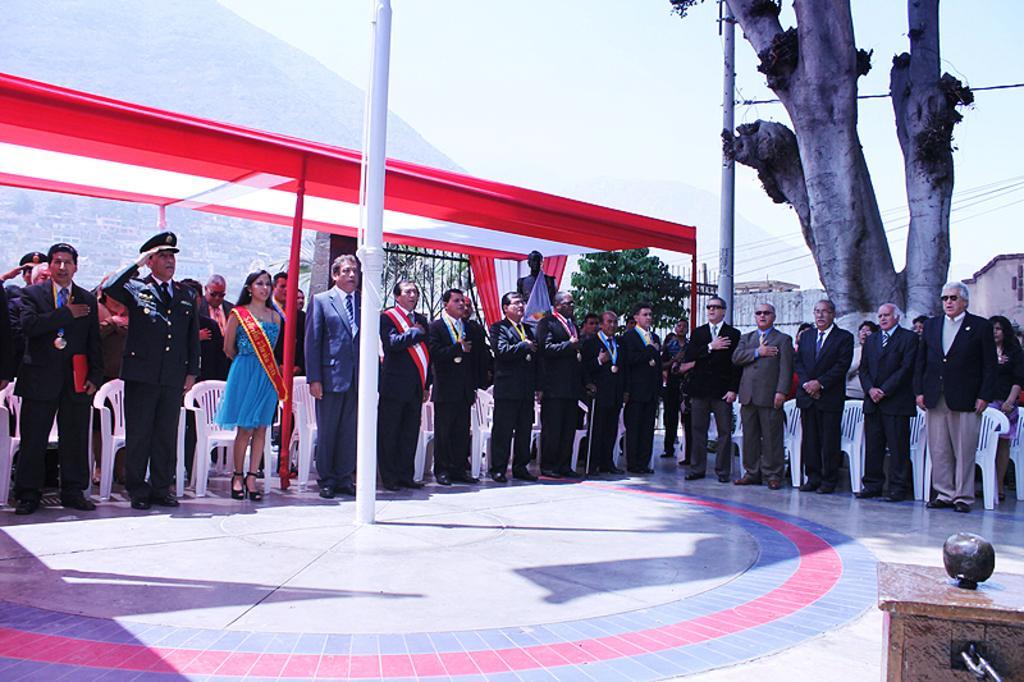In one or two sentences, can you explain what this image depicts? In this image I can see group of people standing. In front the person is wearing blue color dress and I can see the pole in white color. In the background I can see few plants in green color, the railing and I can see the mountains and the sky is in white color and I can see the trunk. 